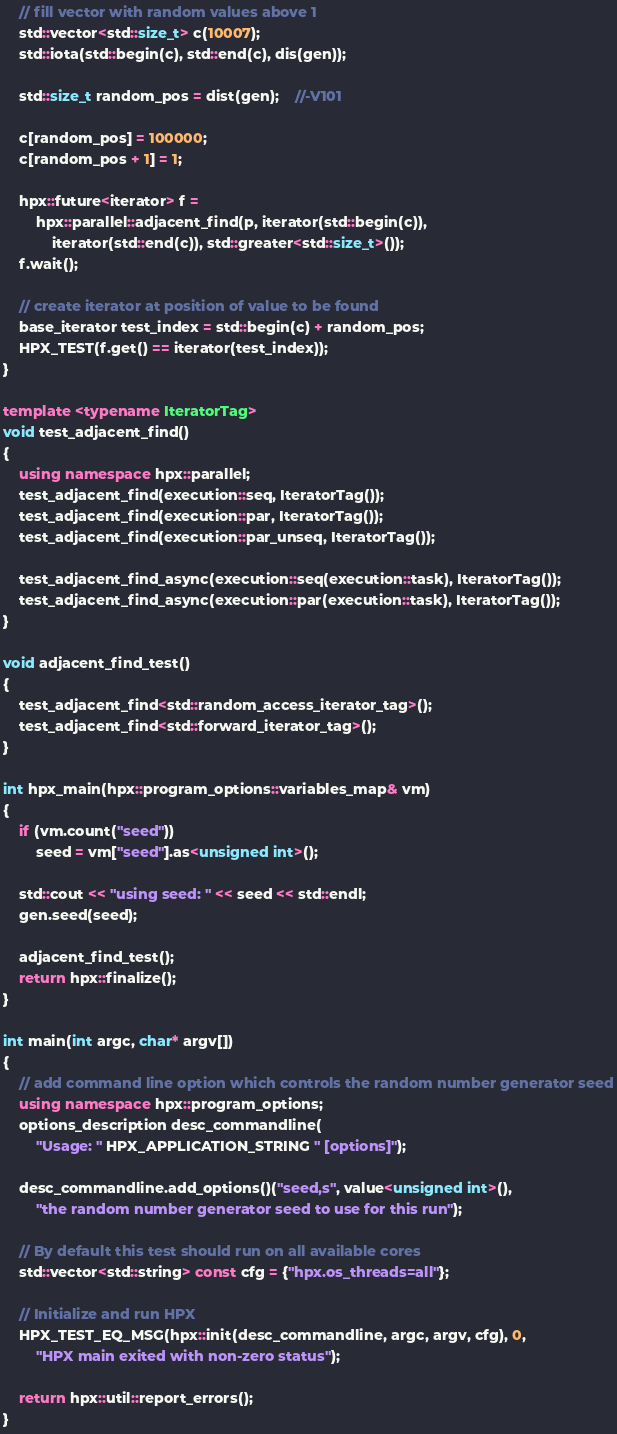<code> <loc_0><loc_0><loc_500><loc_500><_C++_>
    // fill vector with random values above 1
    std::vector<std::size_t> c(10007);
    std::iota(std::begin(c), std::end(c), dis(gen));

    std::size_t random_pos = dist(gen);    //-V101

    c[random_pos] = 100000;
    c[random_pos + 1] = 1;

    hpx::future<iterator> f =
        hpx::parallel::adjacent_find(p, iterator(std::begin(c)),
            iterator(std::end(c)), std::greater<std::size_t>());
    f.wait();

    // create iterator at position of value to be found
    base_iterator test_index = std::begin(c) + random_pos;
    HPX_TEST(f.get() == iterator(test_index));
}

template <typename IteratorTag>
void test_adjacent_find()
{
    using namespace hpx::parallel;
    test_adjacent_find(execution::seq, IteratorTag());
    test_adjacent_find(execution::par, IteratorTag());
    test_adjacent_find(execution::par_unseq, IteratorTag());

    test_adjacent_find_async(execution::seq(execution::task), IteratorTag());
    test_adjacent_find_async(execution::par(execution::task), IteratorTag());
}

void adjacent_find_test()
{
    test_adjacent_find<std::random_access_iterator_tag>();
    test_adjacent_find<std::forward_iterator_tag>();
}

int hpx_main(hpx::program_options::variables_map& vm)
{
    if (vm.count("seed"))
        seed = vm["seed"].as<unsigned int>();

    std::cout << "using seed: " << seed << std::endl;
    gen.seed(seed);

    adjacent_find_test();
    return hpx::finalize();
}

int main(int argc, char* argv[])
{
    // add command line option which controls the random number generator seed
    using namespace hpx::program_options;
    options_description desc_commandline(
        "Usage: " HPX_APPLICATION_STRING " [options]");

    desc_commandline.add_options()("seed,s", value<unsigned int>(),
        "the random number generator seed to use for this run");

    // By default this test should run on all available cores
    std::vector<std::string> const cfg = {"hpx.os_threads=all"};

    // Initialize and run HPX
    HPX_TEST_EQ_MSG(hpx::init(desc_commandline, argc, argv, cfg), 0,
        "HPX main exited with non-zero status");

    return hpx::util::report_errors();
}
</code> 